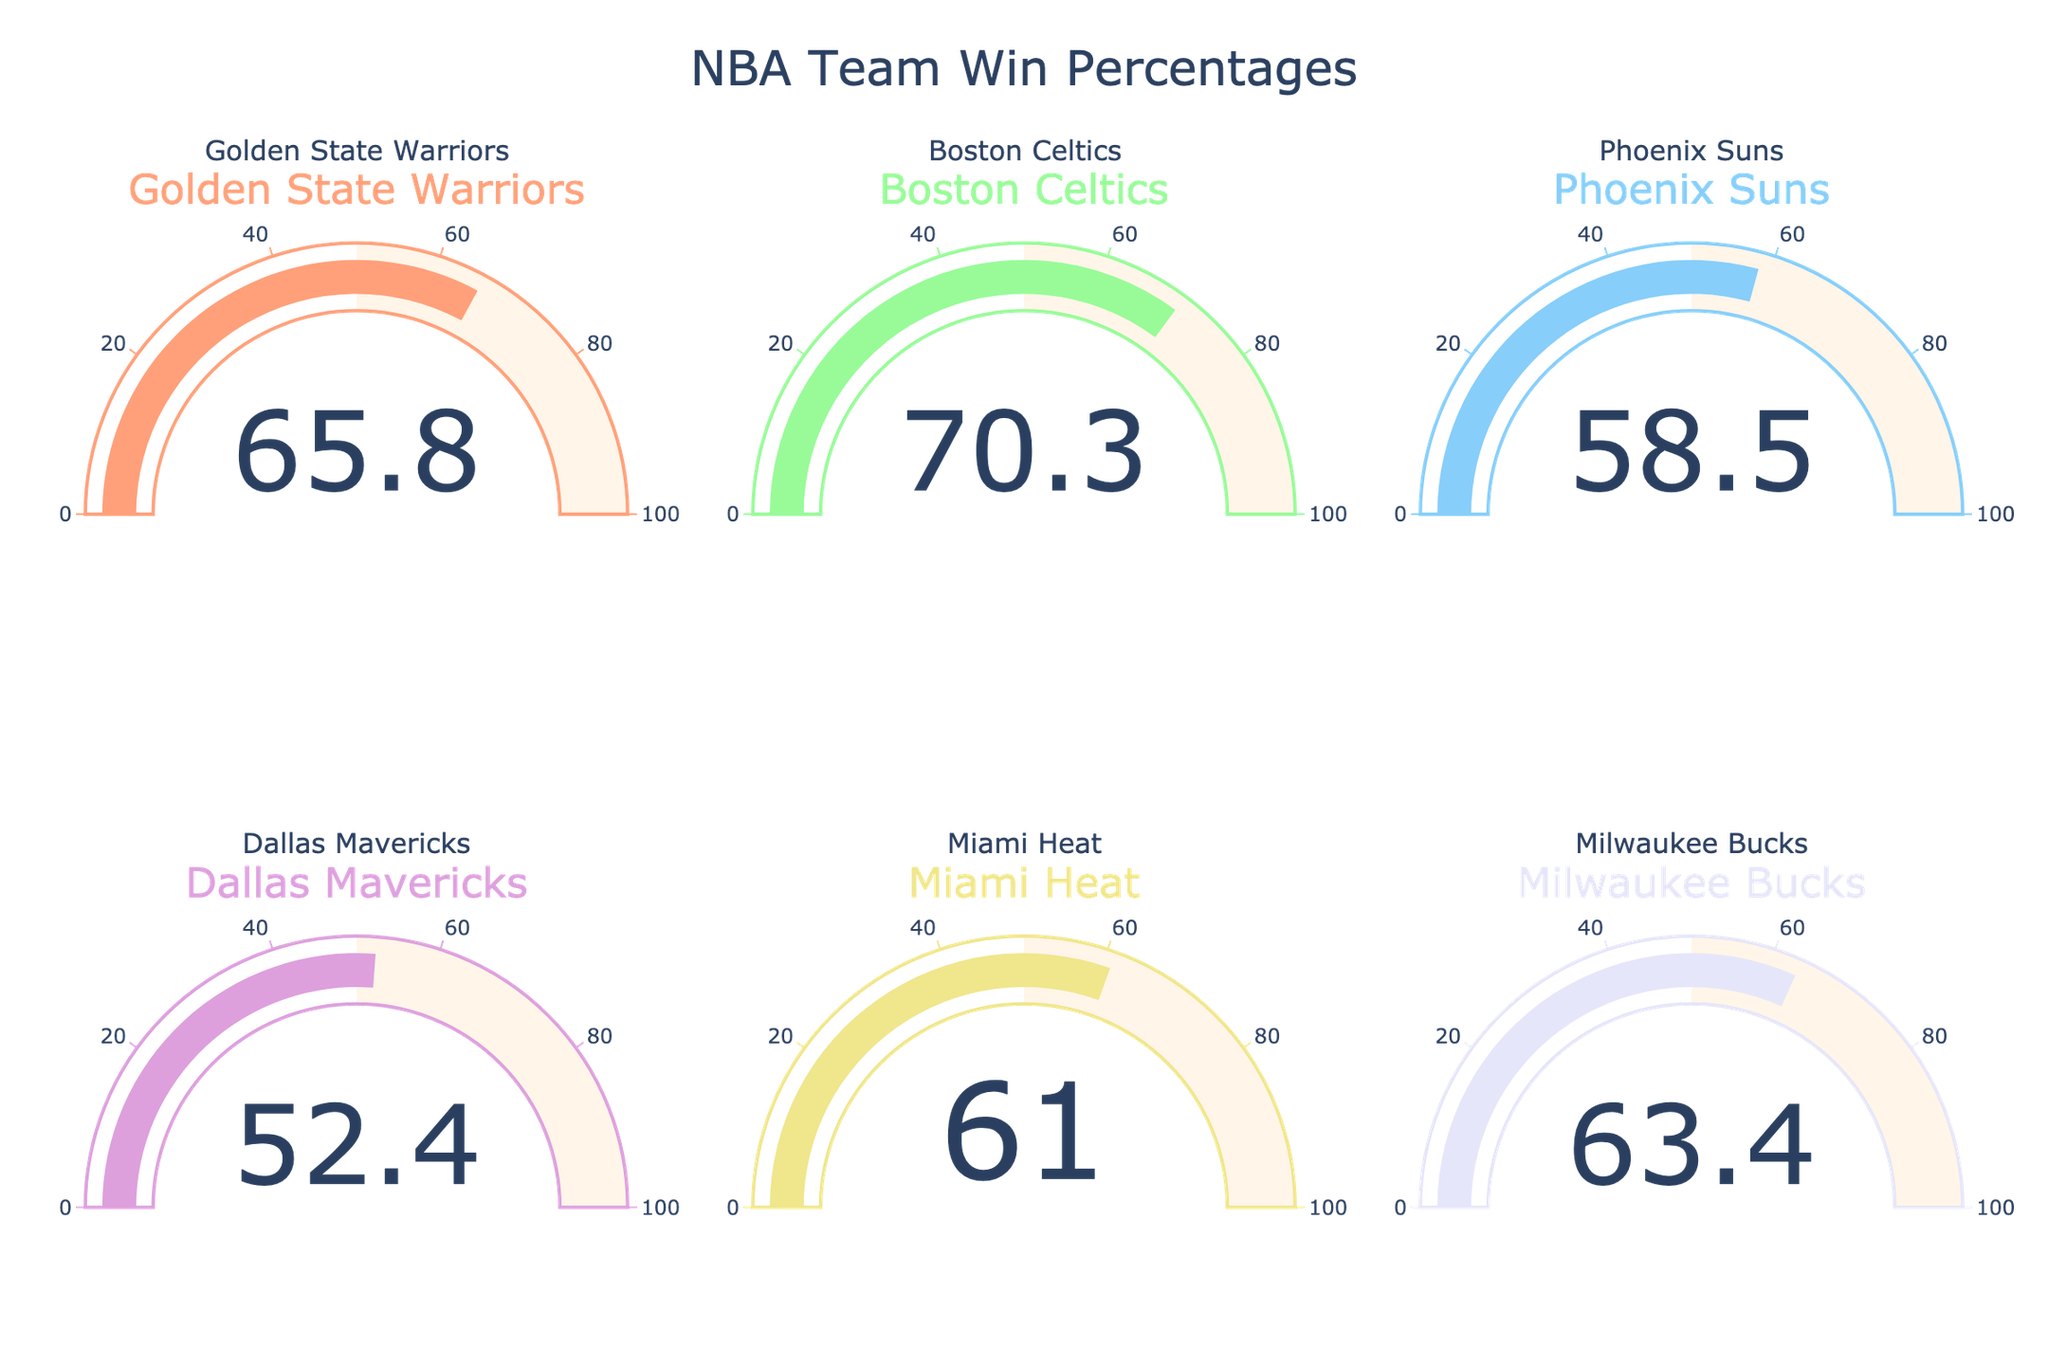What's the win percentage of the team with the highest value? To find the team with the highest win percentage, look at all the gauges and identify the one with the highest number. The Boston Celtics have a win percentage of 70.3%, which is the highest among the teams.
Answer: 70.3% How many teams have a win percentage over 60%? To determine this, look at each gauge and count how many gauges display a number greater than 60. The teams with a win percentage over 60% are the Golden State Warriors, Boston Celtics, Miami Heat, and Milwaukee Bucks, so there are four teams.
Answer: 4 What is the combined win percentage of the Boston Celtics and Miami Heat? Add the win percentages of the Boston Celtics and Miami Heat: 70.3% + 61.0% = 131.3%.
Answer: 131.3% Which team has the lowest win percentage? Compare the values displayed on each gauge and find the smallest one. The Dallas Mavericks have the lowest win percentage at 52.4%.
Answer: Dallas Mavericks How much higher is the win percentage of the Milwaukee Bucks compared to the Phoenix Suns? Subtract the win percentage of the Phoenix Suns from the Milwaukee Bucks: 63.4% - 58.5% = 4.9%.
Answer: 4.9% What is the average win percentage of all six teams? Add all the win percentages and then divide by the number of teams: (65.8 + 70.3 + 58.5 + 52.4 + 61.0 + 63.4) / 6 = 61.9%.
Answer: 61.9% Which team has a win percentage closest to 60%? Compare each team's win percentage to 60% and find the closest one. The Miami Heat have a win percentage of 61.0%, which is closest to 60%.
Answer: Miami Heat What is the difference in win percentage between the highest and lowest teams? Subtract the win percentage of the lowest team (Dallas Mavericks, 52.4%) from the highest team (Boston Celtics, 70.3%): 70.3% - 52.4% = 17.9%.
Answer: 17.9% Which team is in the middle when ranking win percentages from highest to lowest? Arrange the teams by their win percentages: 70.3% (Boston Celtics), 65.8% (Golden State Warriors), 63.4% (Milwaukee Bucks), 61.0% (Miami Heat), 58.5% (Phoenix Suns), 52.4% (Dallas Mavericks). The Miami Heat is in the middle position when ranked from highest to lowest.
Answer: Miami Heat 